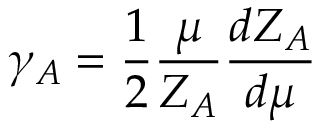Convert formula to latex. <formula><loc_0><loc_0><loc_500><loc_500>\gamma _ { A } = \frac { 1 } { 2 } \frac { \mu } { Z _ { A } } \frac { d Z _ { A } } { d \mu }</formula> 